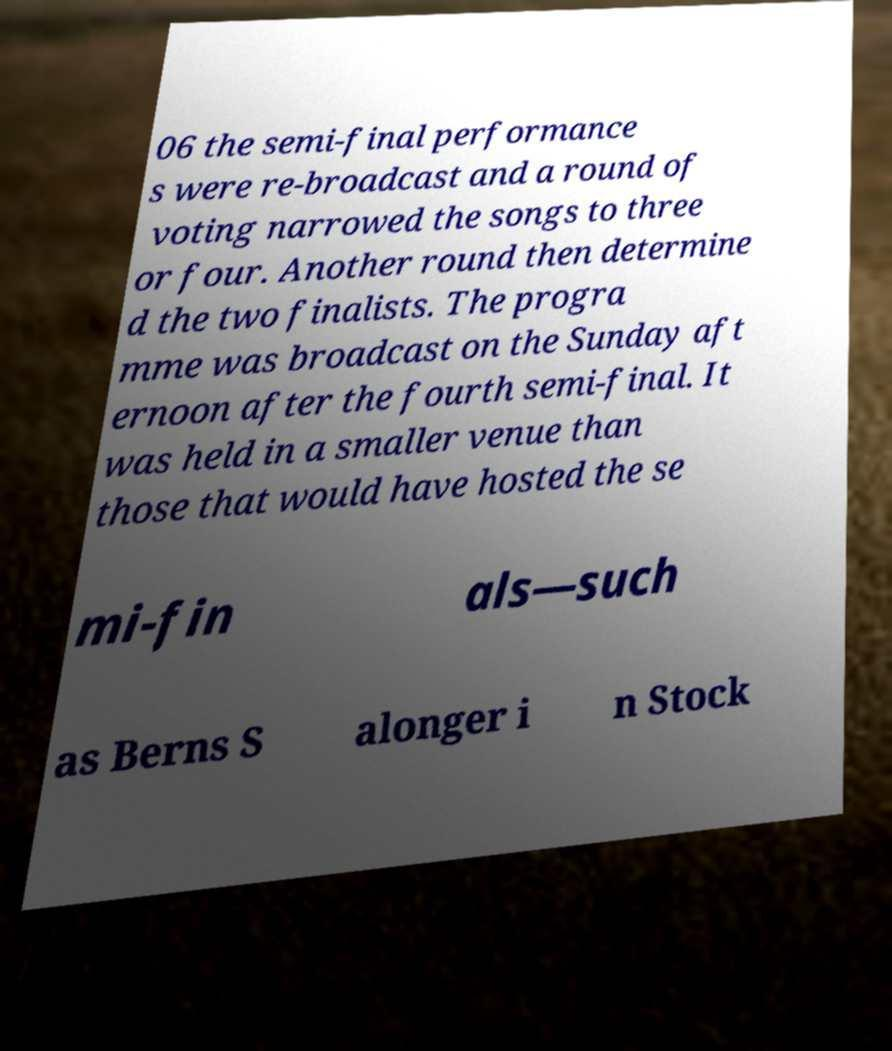Please identify and transcribe the text found in this image. 06 the semi-final performance s were re-broadcast and a round of voting narrowed the songs to three or four. Another round then determine d the two finalists. The progra mme was broadcast on the Sunday aft ernoon after the fourth semi-final. It was held in a smaller venue than those that would have hosted the se mi-fin als—such as Berns S alonger i n Stock 